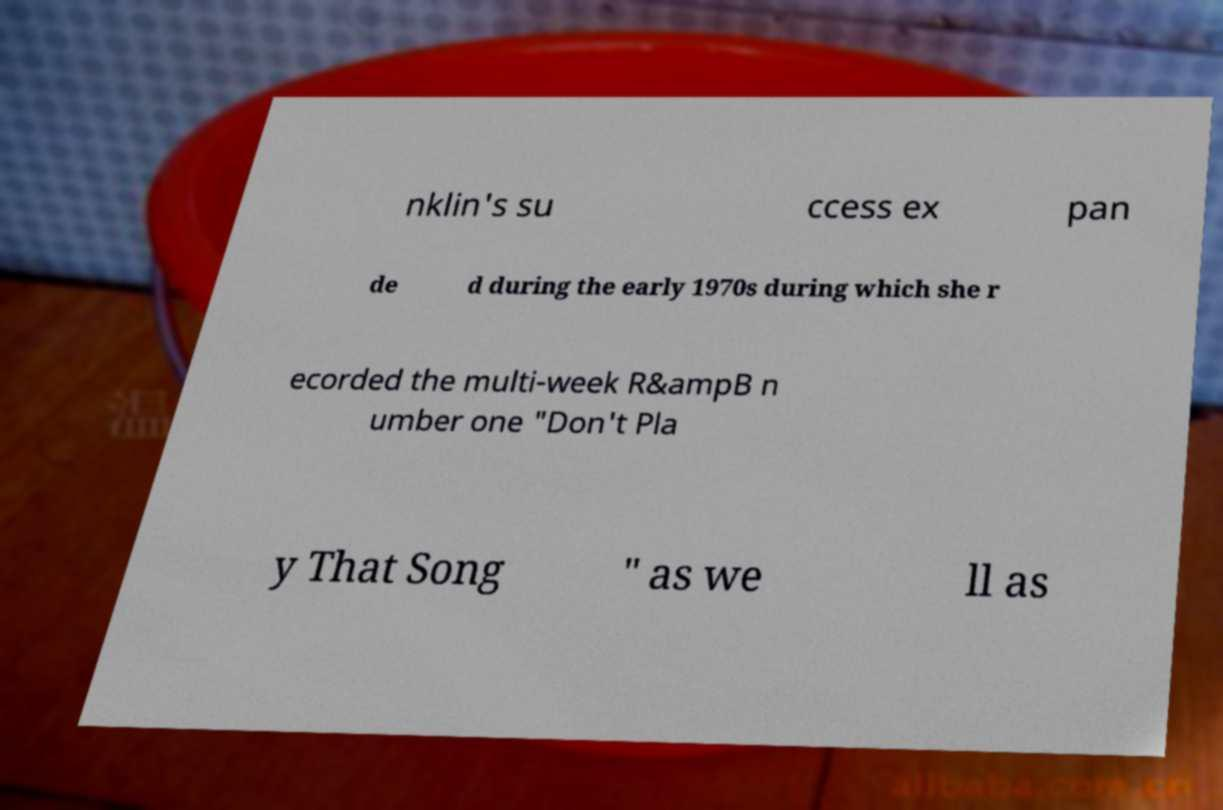There's text embedded in this image that I need extracted. Can you transcribe it verbatim? nklin's su ccess ex pan de d during the early 1970s during which she r ecorded the multi-week R&ampB n umber one "Don't Pla y That Song " as we ll as 